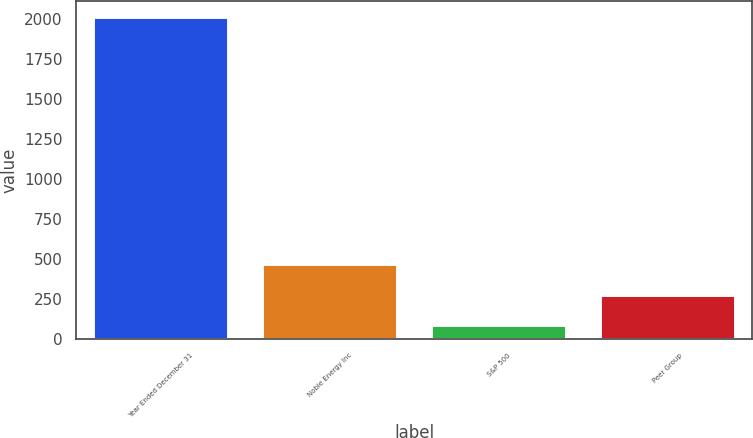Convert chart. <chart><loc_0><loc_0><loc_500><loc_500><bar_chart><fcel>Year Ended December 31<fcel>Noble Energy Inc<fcel>S&P 500<fcel>Peer Group<nl><fcel>2009<fcel>469.05<fcel>84.05<fcel>276.55<nl></chart> 